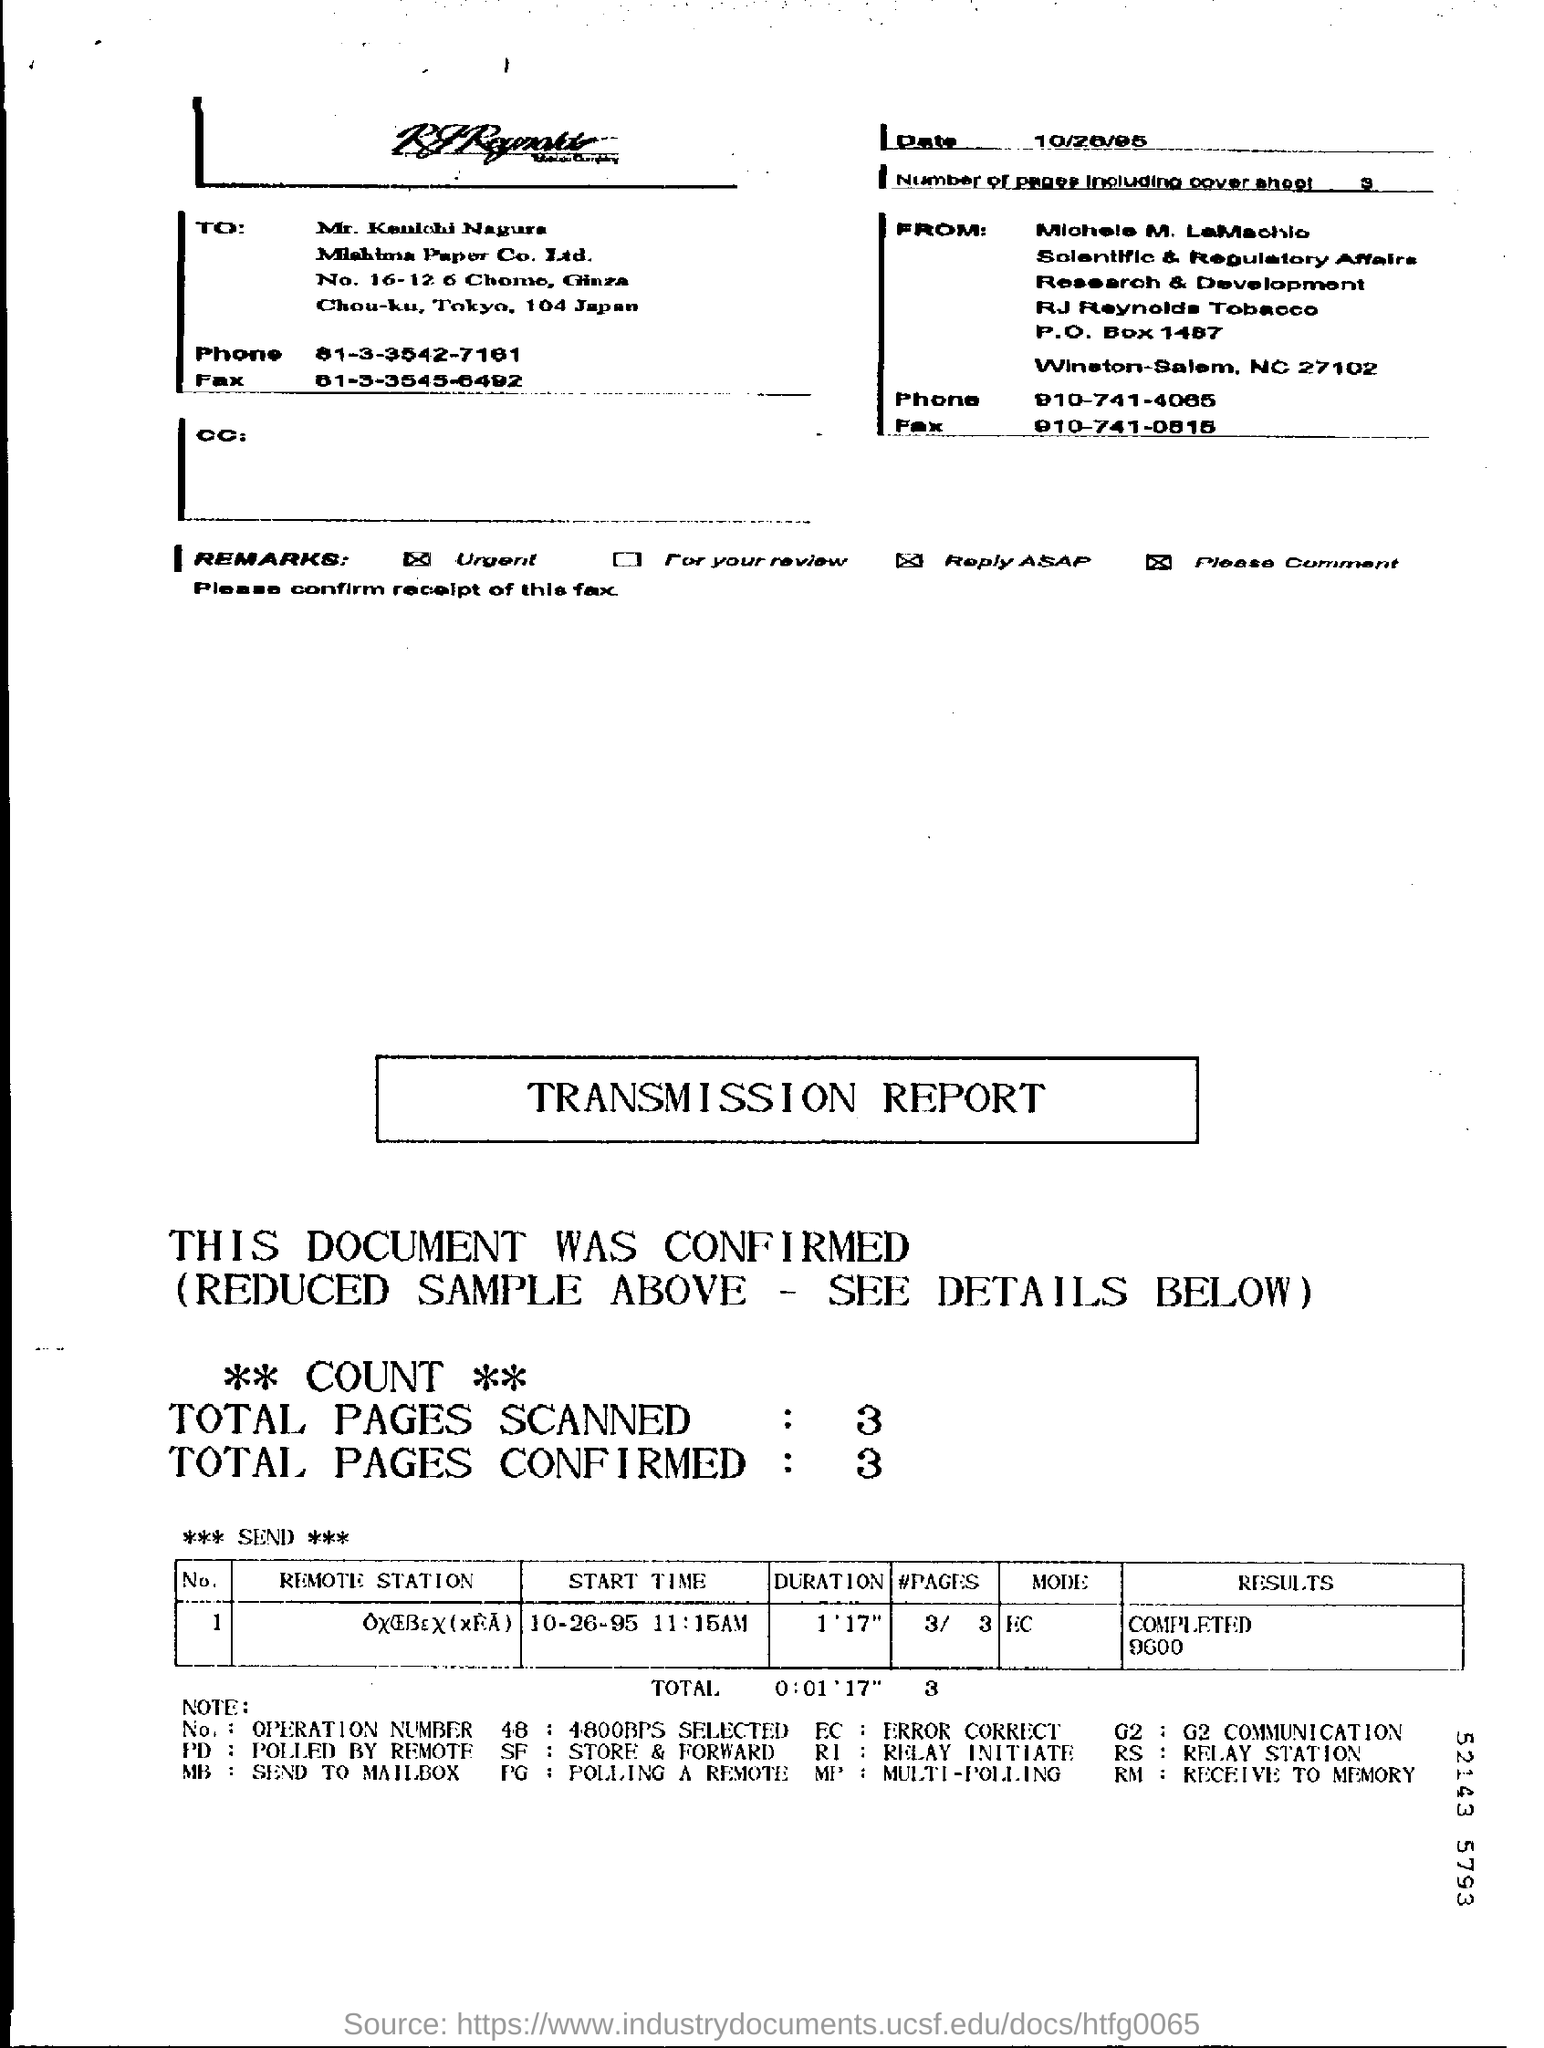Give some essential details in this illustration. The phone number of Michele M. LaMachio is 910-741-4065. The mode of the transmission report is EC. The number of pages in the fax, including the cover sheet, is three. The duration mentioned in the transmission report is 1 minute and 17 seconds. 